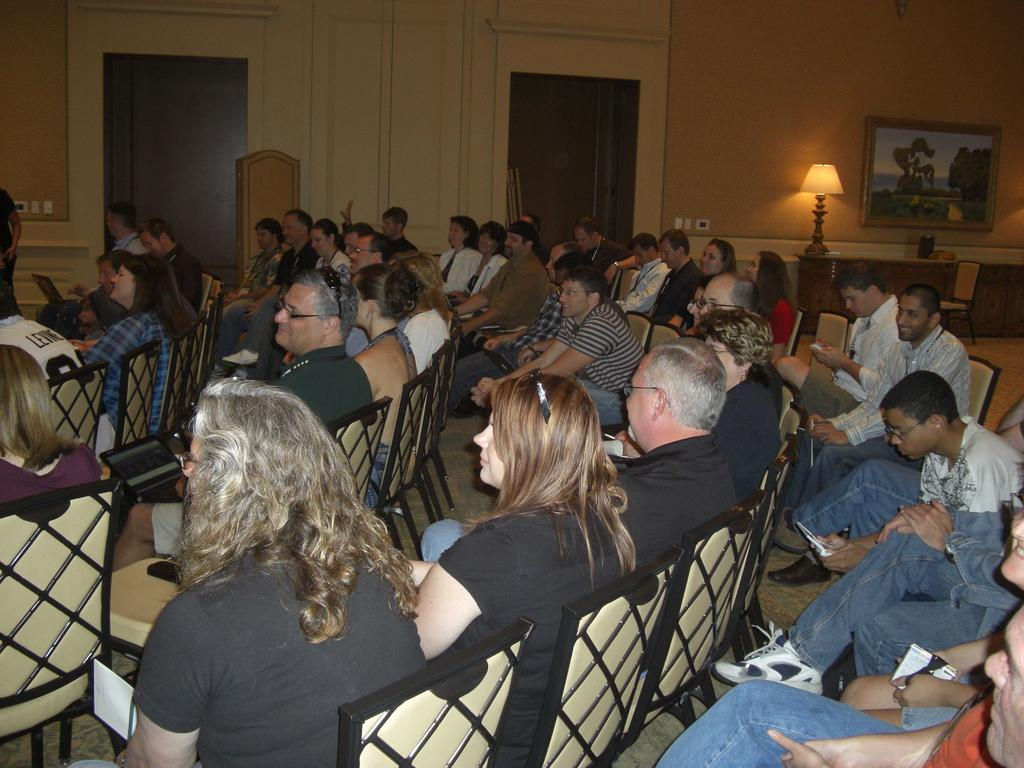How many people are seated in the image? There are many people seated on chairs in the image. Where are the people seated? The people are in a room. What can be seen in the room besides the people? There is a lamp and a photo frame in the image. How many doorways are visible in the room? There are two doorways at the back of the room in the image. What type of mask is the ant wearing in the image? There is no ant or mask present in the image. How can the people push the doorways open in the image? The question is not relevant to the image, as it does not involve any action or interaction with the doorways. 